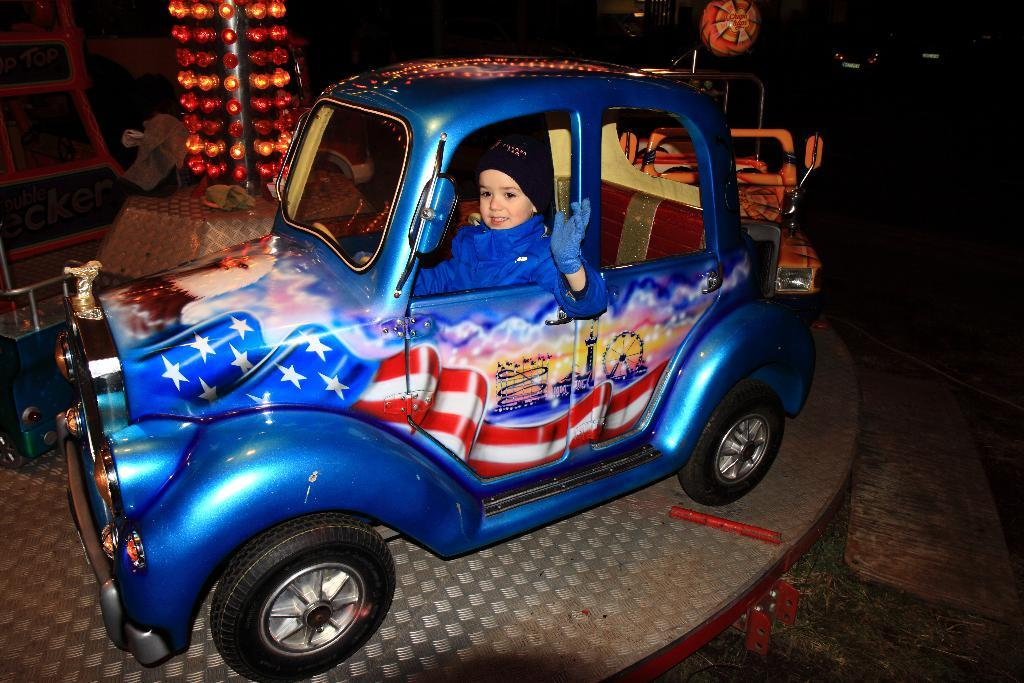What is the child doing in the image? The child is sitting in a toy car. Where is the toy car located? The toy car is placed on the floor. What can be seen in the background or surrounding the toy car? There are lights visible in the image, as well as a wooden board and other objects. Are there any other toy cars in the image? Yes, there is another toy car in the image. What position does the yak hold in the image? There is no yak present in the image. What trick is the child performing with the toy car? The image does not depict the child performing any tricks with the toy car; they are simply sitting in it. 